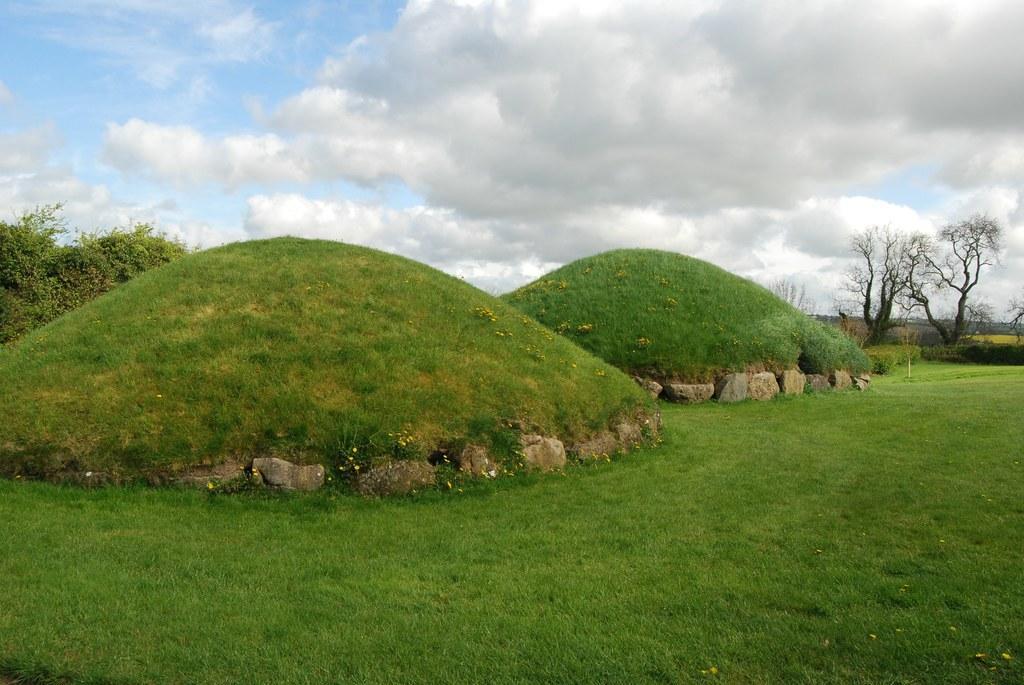Please provide a concise description of this image. In this image I can see grass ground in the front and in the background I can see few trees, clouds and the sky. 